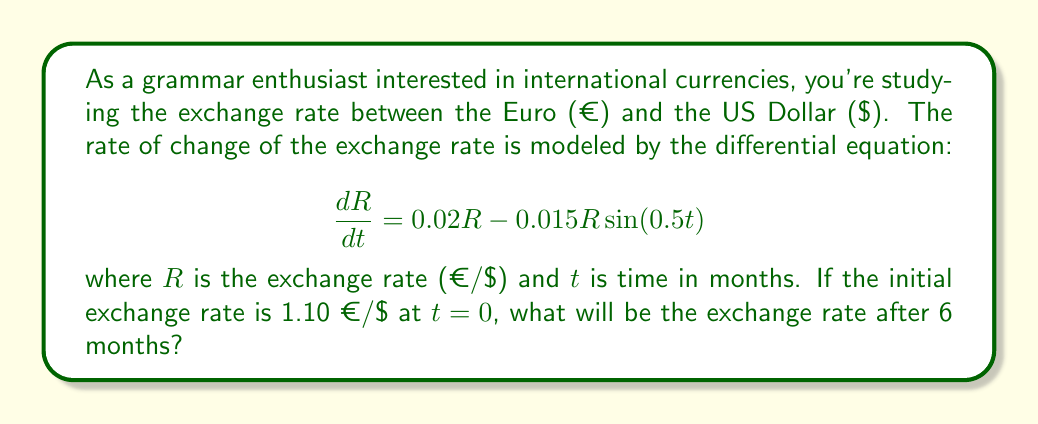Could you help me with this problem? To solve this problem, we need to use the given differential equation and initial condition. Let's approach this step-by-step:

1) The given differential equation is:

   $$\frac{dR}{dt} = 0.02R - 0.015R\sin(0.5t)$$

2) This is a linear first-order differential equation. It can be rewritten as:

   $$\frac{dR}{dt} = R(0.02 - 0.015\sin(0.5t))$$

3) The general solution for this type of equation is:

   $$R = Ce^{\int (0.02 - 0.015\sin(0.5t)) dt}$$

   where $C$ is a constant to be determined by the initial condition.

4) Let's solve the integral:

   $$\int (0.02 - 0.015\sin(0.5t)) dt = 0.02t + 0.03\cos(0.5t) + K$$

   where $K$ is the constant of integration.

5) Therefore, the general solution is:

   $$R = Ce^{0.02t + 0.03\cos(0.5t)}$$

6) Now we use the initial condition: $R = 1.10$ when $t = 0$

   $$1.10 = Ce^{0.02(0) + 0.03\cos(0.5(0))} = Ce^{0.03}$$

   $$C = 1.10e^{-0.03}$$

7) So, the particular solution is:

   $$R = 1.10e^{-0.03} \cdot e^{0.02t + 0.03\cos(0.5t)}$$

8) To find the exchange rate after 6 months, we substitute $t = 6$:

   $$R = 1.10e^{-0.03} \cdot e^{0.02(6) + 0.03\cos(0.5(6))}$$

9) Calculating this:

   $$R = 1.10e^{-0.03} \cdot e^{0.12 + 0.03\cos(3)} \approx 1.2178$$

Therefore, after 6 months, the exchange rate will be approximately 1.2178 €/$.
Answer: $1.2178$ €/$ 